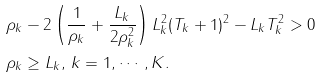Convert formula to latex. <formula><loc_0><loc_0><loc_500><loc_500>& { \rho _ { k } } - 2 \left ( \frac { 1 } { \rho _ { k } } + \frac { L _ { k } } { 2 \rho _ { k } ^ { 2 } } \right ) L ^ { 2 } _ { k } ( T _ { k } + 1 ) ^ { 2 } - L _ { k } T ^ { 2 } _ { k } > 0 \\ & \rho _ { k } \geq L _ { k } , \, k = 1 , \cdots , K .</formula> 